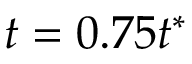<formula> <loc_0><loc_0><loc_500><loc_500>t = 0 . 7 5 t ^ { * }</formula> 